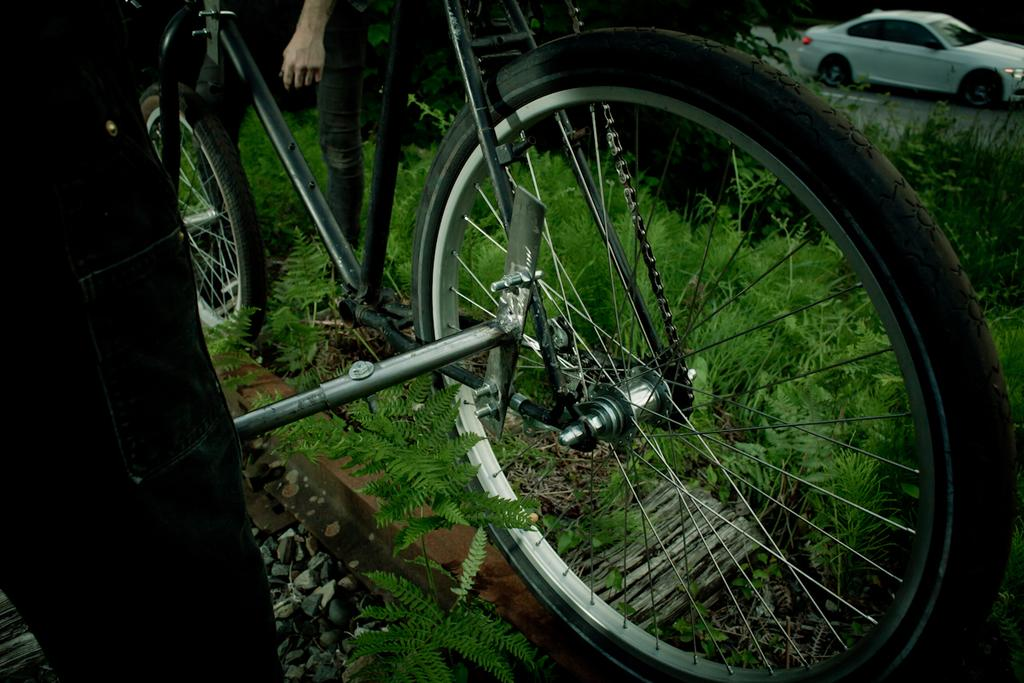What is the main object in the image? There is a bicycle in the image. Where is the person standing in the image? The person is standing on the grass ground. What type of vehicle can be seen on the road in the image? There is a white color car on the road in the top right side of the image. How many ants are crawling on the bicycle in the image? There are no ants visible on the bicycle in the image. What is the cause of the person's attention in the image? The provided facts do not mention the person's attention or any specific cause for it. 